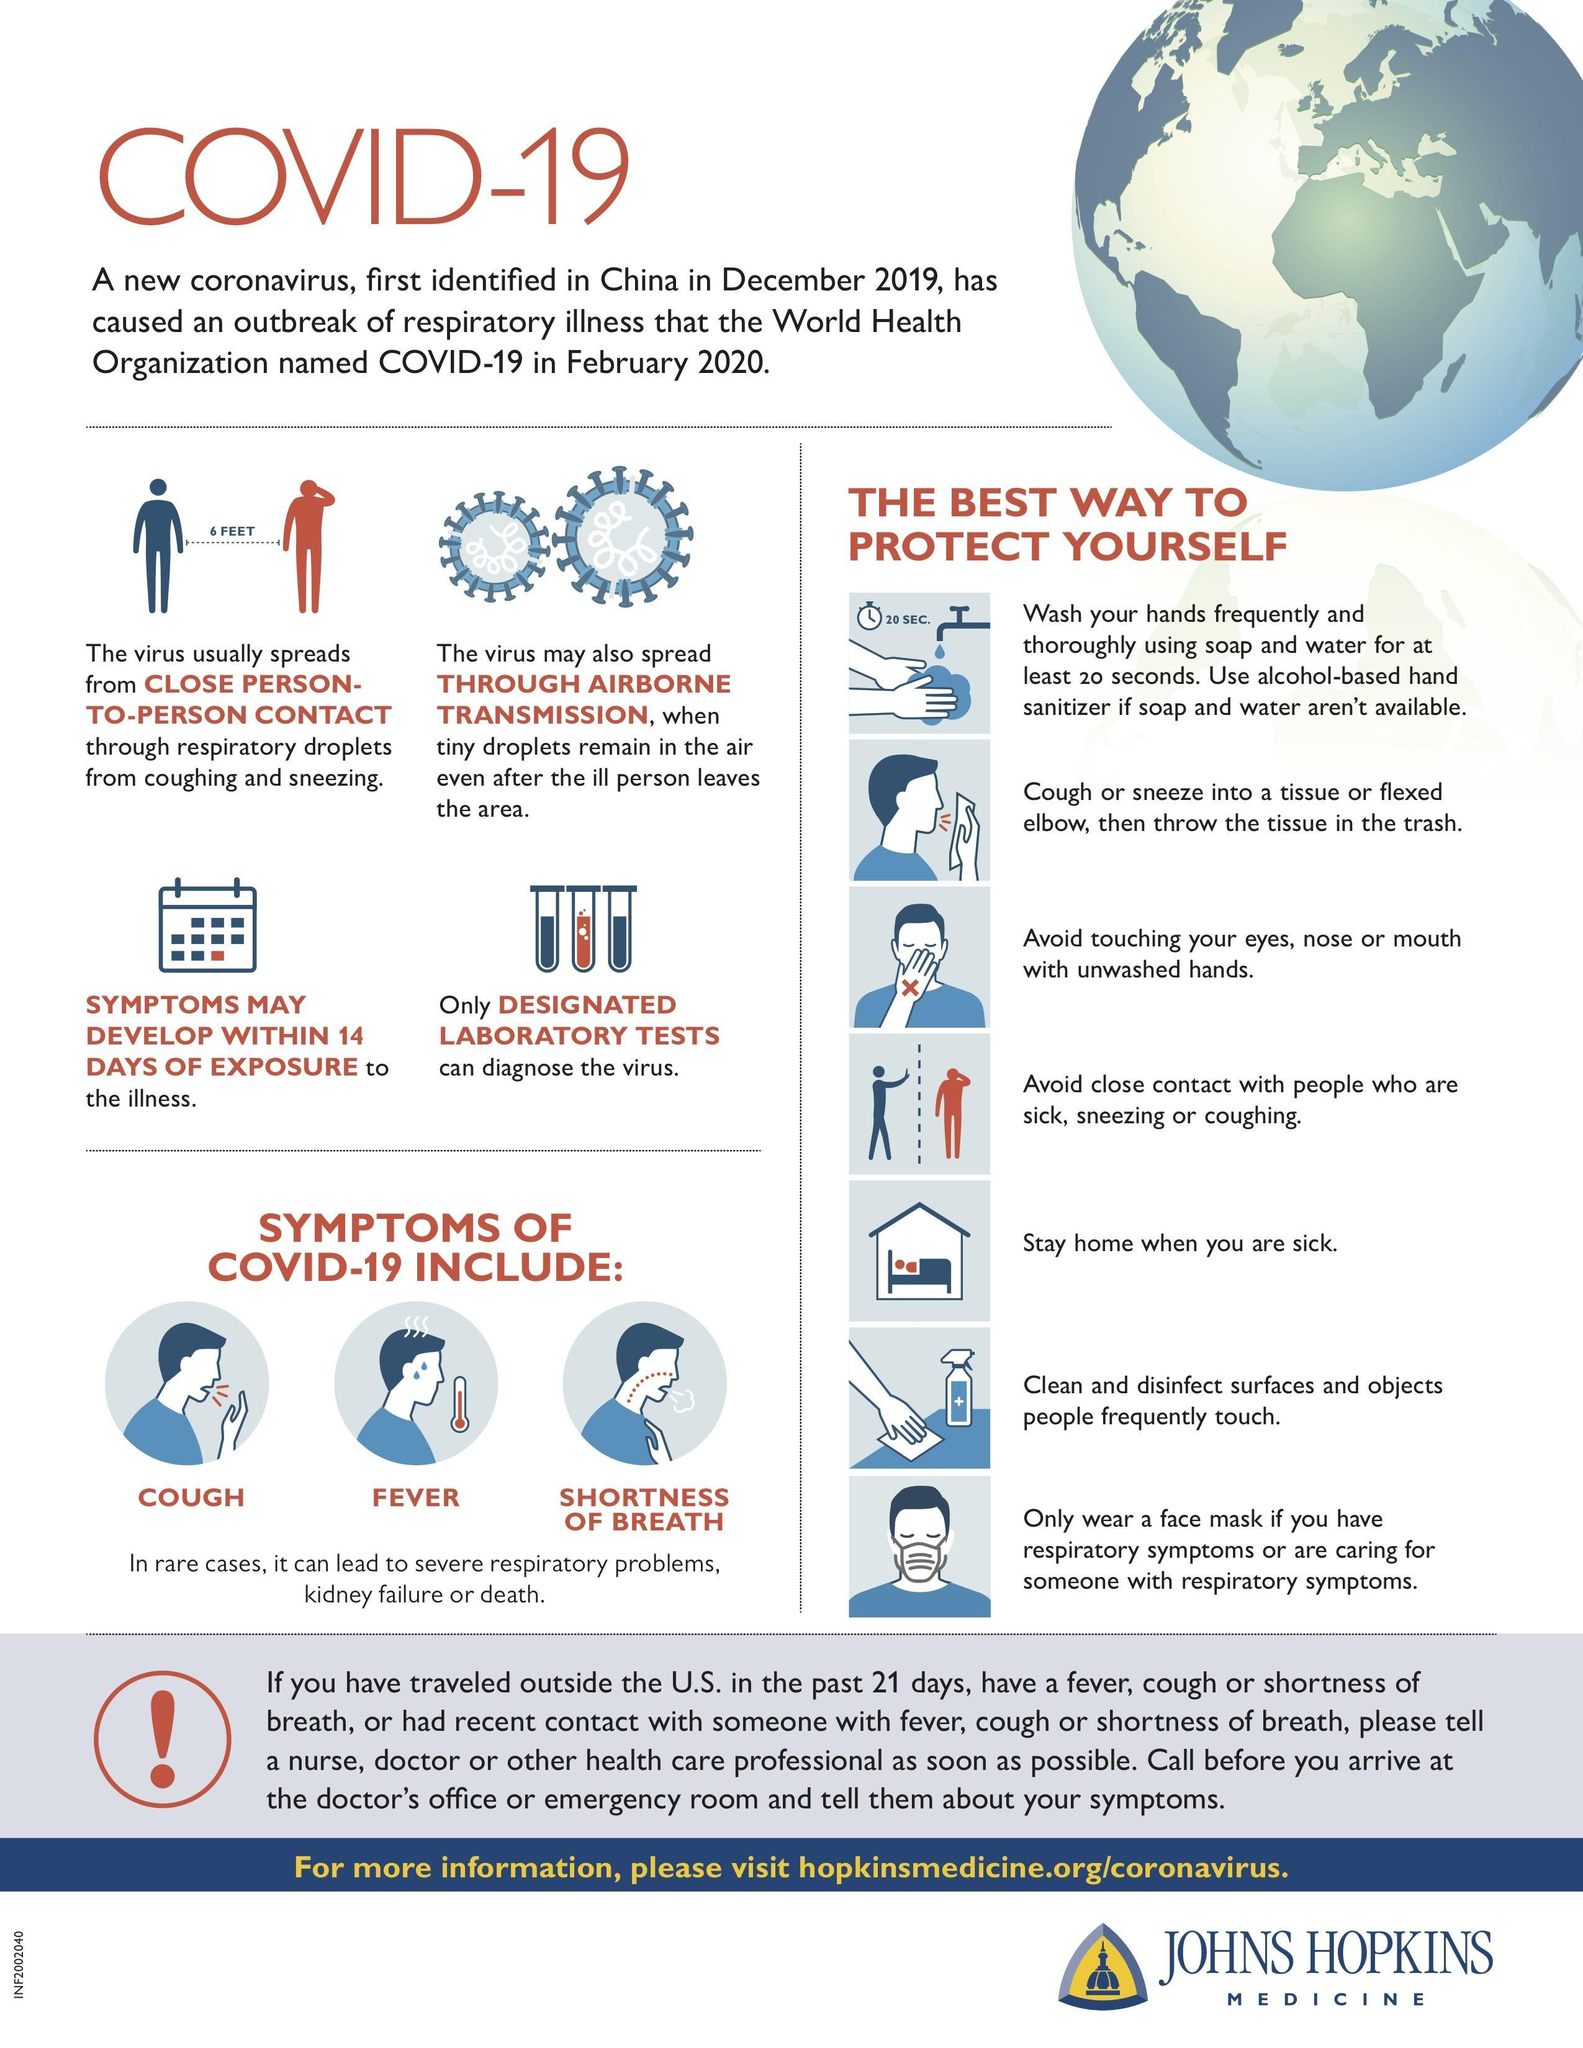What are the common symptoms of COVID-19?
Answer the question with a short phrase. COUGH, FEVER, SHORTNESS OF BREATH How long does it take for symptoms of the coronavirus disease to appear? within 14 days What is the minimum safe distance to be maintained by each individual inorder to control the spread of COVID-19 virus? 6 FEET 